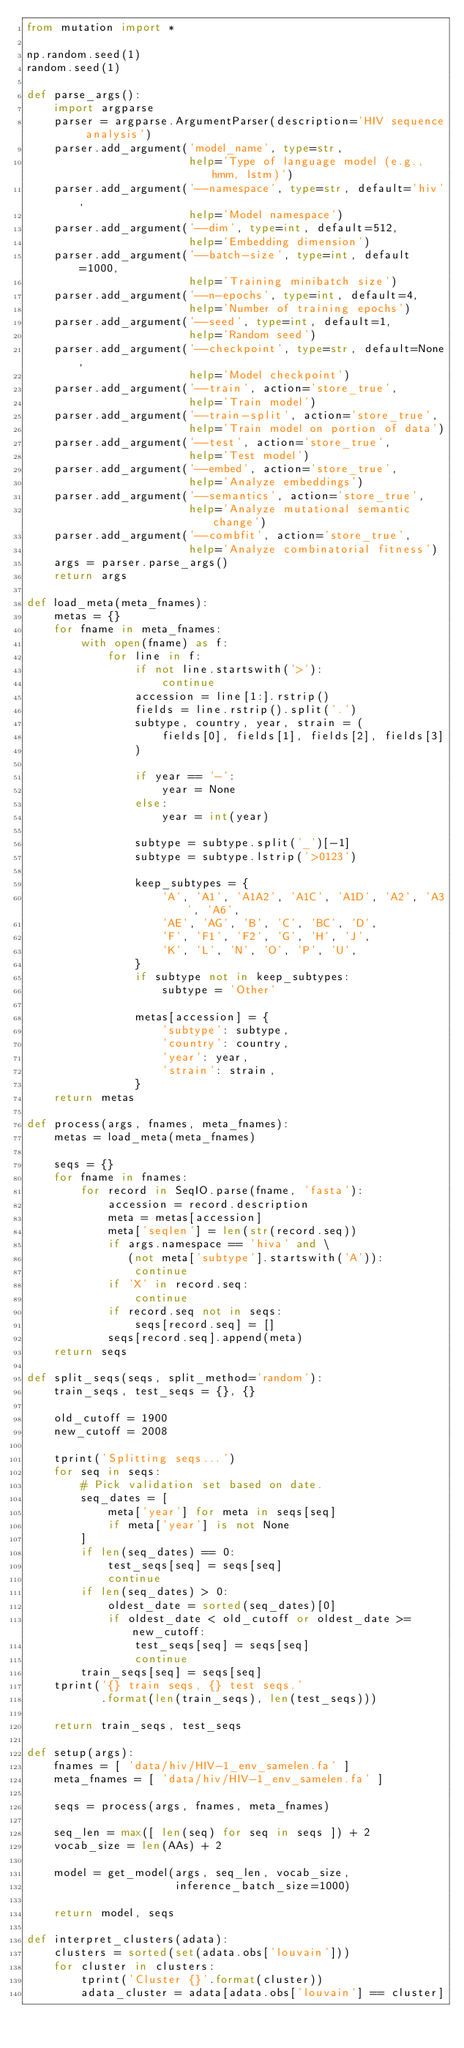Convert code to text. <code><loc_0><loc_0><loc_500><loc_500><_Python_>from mutation import *

np.random.seed(1)
random.seed(1)

def parse_args():
    import argparse
    parser = argparse.ArgumentParser(description='HIV sequence analysis')
    parser.add_argument('model_name', type=str,
                        help='Type of language model (e.g., hmm, lstm)')
    parser.add_argument('--namespace', type=str, default='hiv',
                        help='Model namespace')
    parser.add_argument('--dim', type=int, default=512,
                        help='Embedding dimension')
    parser.add_argument('--batch-size', type=int, default=1000,
                        help='Training minibatch size')
    parser.add_argument('--n-epochs', type=int, default=4,
                        help='Number of training epochs')
    parser.add_argument('--seed', type=int, default=1,
                        help='Random seed')
    parser.add_argument('--checkpoint', type=str, default=None,
                        help='Model checkpoint')
    parser.add_argument('--train', action='store_true',
                        help='Train model')
    parser.add_argument('--train-split', action='store_true',
                        help='Train model on portion of data')
    parser.add_argument('--test', action='store_true',
                        help='Test model')
    parser.add_argument('--embed', action='store_true',
                        help='Analyze embeddings')
    parser.add_argument('--semantics', action='store_true',
                        help='Analyze mutational semantic change')
    parser.add_argument('--combfit', action='store_true',
                        help='Analyze combinatorial fitness')
    args = parser.parse_args()
    return args

def load_meta(meta_fnames):
    metas = {}
    for fname in meta_fnames:
        with open(fname) as f:
            for line in f:
                if not line.startswith('>'):
                    continue
                accession = line[1:].rstrip()
                fields = line.rstrip().split('.')
                subtype, country, year, strain = (
                    fields[0], fields[1], fields[2], fields[3]
                )

                if year == '-':
                    year = None
                else:
                    year = int(year)

                subtype = subtype.split('_')[-1]
                subtype = subtype.lstrip('>0123')

                keep_subtypes = {
                    'A', 'A1', 'A1A2', 'A1C', 'A1D', 'A2', 'A3', 'A6',
                    'AE', 'AG', 'B', 'C', 'BC', 'D',
                    'F', 'F1', 'F2', 'G', 'H', 'J',
                    'K', 'L', 'N', 'O', 'P', 'U',
                }
                if subtype not in keep_subtypes:
                    subtype = 'Other'

                metas[accession] = {
                    'subtype': subtype,
                    'country': country,
                    'year': year,
                    'strain': strain,
                }
    return metas

def process(args, fnames, meta_fnames):
    metas = load_meta(meta_fnames)

    seqs = {}
    for fname in fnames:
        for record in SeqIO.parse(fname, 'fasta'):
            accession = record.description
            meta = metas[accession]
            meta['seqlen'] = len(str(record.seq))
            if args.namespace == 'hiva' and \
               (not meta['subtype'].startswith('A')):
                continue
            if 'X' in record.seq:
                continue
            if record.seq not in seqs:
                seqs[record.seq] = []
            seqs[record.seq].append(meta)
    return seqs

def split_seqs(seqs, split_method='random'):
    train_seqs, test_seqs = {}, {}

    old_cutoff = 1900
    new_cutoff = 2008

    tprint('Splitting seqs...')
    for seq in seqs:
        # Pick validation set based on date.
        seq_dates = [
            meta['year'] for meta in seqs[seq]
            if meta['year'] is not None
        ]
        if len(seq_dates) == 0:
            test_seqs[seq] = seqs[seq]
            continue
        if len(seq_dates) > 0:
            oldest_date = sorted(seq_dates)[0]
            if oldest_date < old_cutoff or oldest_date >= new_cutoff:
                test_seqs[seq] = seqs[seq]
                continue
        train_seqs[seq] = seqs[seq]
    tprint('{} train seqs, {} test seqs.'
           .format(len(train_seqs), len(test_seqs)))

    return train_seqs, test_seqs

def setup(args):
    fnames = [ 'data/hiv/HIV-1_env_samelen.fa' ]
    meta_fnames = [ 'data/hiv/HIV-1_env_samelen.fa' ]

    seqs = process(args, fnames, meta_fnames)

    seq_len = max([ len(seq) for seq in seqs ]) + 2
    vocab_size = len(AAs) + 2

    model = get_model(args, seq_len, vocab_size,
                      inference_batch_size=1000)

    return model, seqs

def interpret_clusters(adata):
    clusters = sorted(set(adata.obs['louvain']))
    for cluster in clusters:
        tprint('Cluster {}'.format(cluster))
        adata_cluster = adata[adata.obs['louvain'] == cluster]</code> 